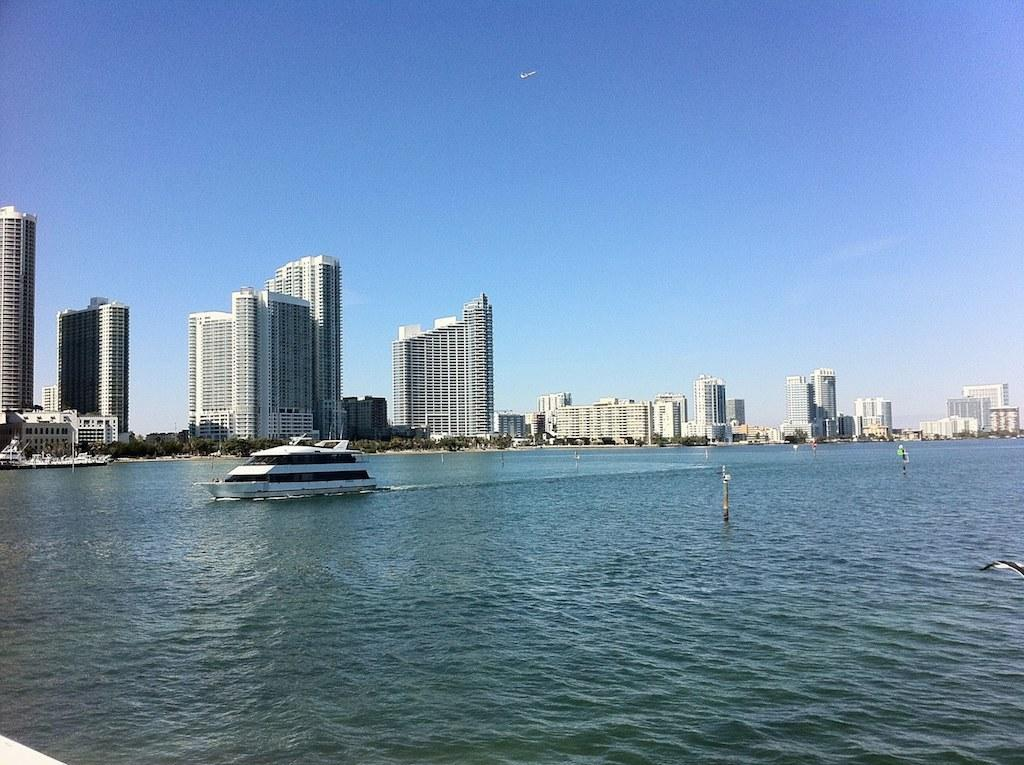What is the main subject of the image? The main subject of the image is a ship. Where is the ship located in the image? The ship is on the surface of water. What can be seen in the background of the image? There are buildings and trees in the background of the image. What is visible at the top of the image? The sky is visible at the top of the image. What type of cloth is being used to cover the amusement park in the image? There is no amusement park or cloth present in the image. The image features a ship on the water with buildings, trees, and the sky in the background. 